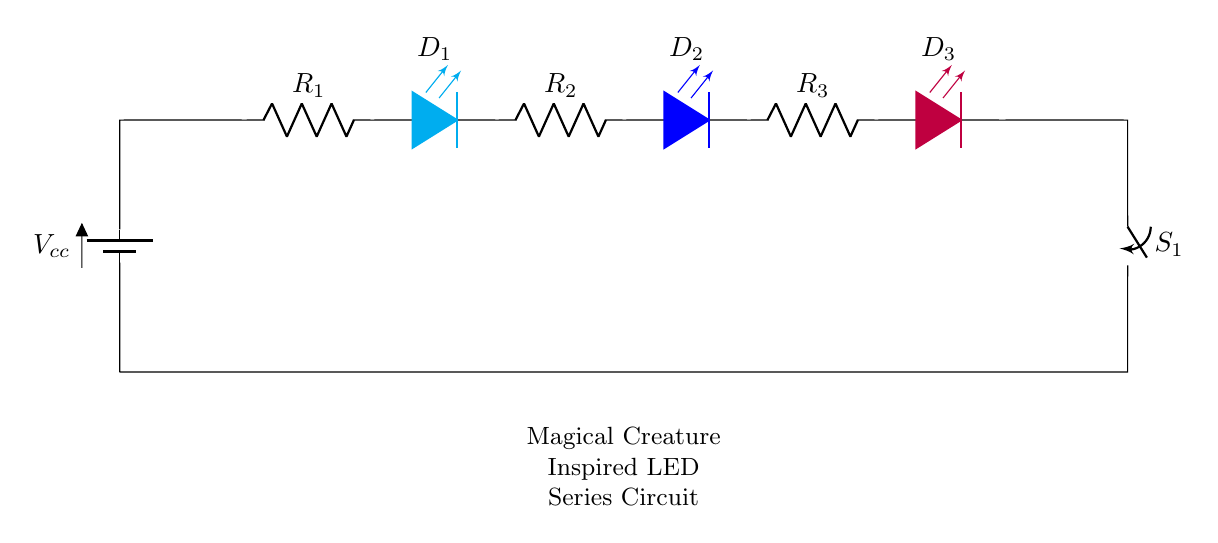What is the total number of LEDs in the circuit? There are three LEDs in the circuit as indicated by the symbols for D1, D2, and D3 in the diagram.
Answer: three What colors are the LEDs in the circuit? The colors of the LEDs are cyan for D1, blue for D2, and purple for D3, as shown in the diagram next to each LED symbol.
Answer: cyan, blue, purple What is the role of the switch in this circuit? The switch connects or disconnects the circuit, allowing the flow of current to the LEDs when closed and stopping it when open.
Answer: control current flow Which component would be used to limit current to the LEDs? The resistors R1, R2, and R3 are used to limit current, as they are placed in series with each LED.
Answer: resistors What will happen if the circuit is powered without a resistor? Without a resistor, excessive current could flow through the LEDs, likely causing them to burn out due to overheating.
Answer: LEDs may burn out What does the battery represent in this circuit? The battery represents the power source, providing the necessary voltage to energize the circuit and power the LEDs.
Answer: power source How many resistors are present in the circuit? There are three resistors in the circuit labeled R1, R2, and R3, which are positioned in series with the LEDs.
Answer: three 